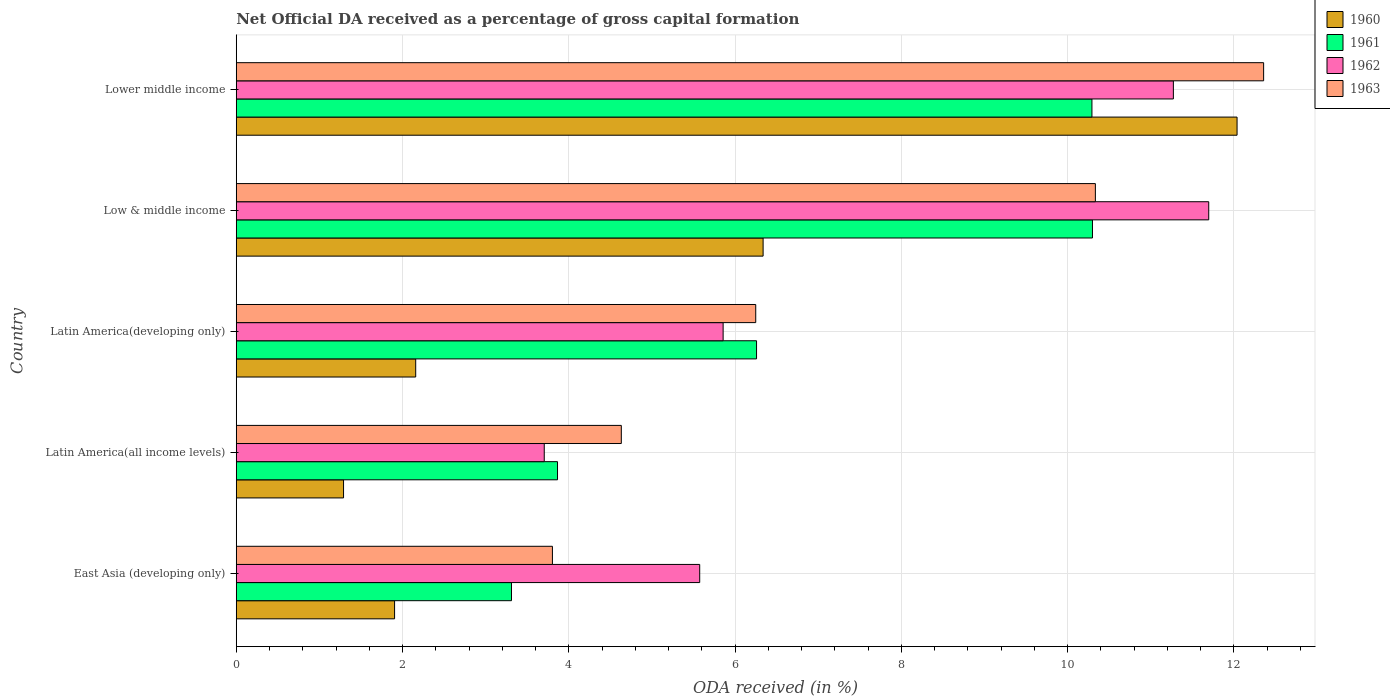How many different coloured bars are there?
Your response must be concise. 4. Are the number of bars per tick equal to the number of legend labels?
Your answer should be very brief. Yes. Are the number of bars on each tick of the Y-axis equal?
Keep it short and to the point. Yes. How many bars are there on the 1st tick from the top?
Offer a terse response. 4. What is the label of the 5th group of bars from the top?
Keep it short and to the point. East Asia (developing only). What is the net ODA received in 1960 in East Asia (developing only)?
Your answer should be very brief. 1.9. Across all countries, what is the maximum net ODA received in 1962?
Your response must be concise. 11.7. Across all countries, what is the minimum net ODA received in 1963?
Keep it short and to the point. 3.8. In which country was the net ODA received in 1960 maximum?
Offer a very short reply. Lower middle income. In which country was the net ODA received in 1962 minimum?
Give a very brief answer. Latin America(all income levels). What is the total net ODA received in 1963 in the graph?
Provide a short and direct response. 37.37. What is the difference between the net ODA received in 1962 in Latin America(all income levels) and that in Latin America(developing only)?
Offer a terse response. -2.15. What is the difference between the net ODA received in 1963 in Latin America(developing only) and the net ODA received in 1961 in Low & middle income?
Keep it short and to the point. -4.05. What is the average net ODA received in 1961 per country?
Offer a terse response. 6.8. What is the difference between the net ODA received in 1963 and net ODA received in 1962 in Lower middle income?
Your answer should be very brief. 1.09. What is the ratio of the net ODA received in 1962 in Low & middle income to that in Lower middle income?
Keep it short and to the point. 1.04. What is the difference between the highest and the second highest net ODA received in 1963?
Ensure brevity in your answer.  2.02. What is the difference between the highest and the lowest net ODA received in 1962?
Ensure brevity in your answer.  7.99. In how many countries, is the net ODA received in 1960 greater than the average net ODA received in 1960 taken over all countries?
Provide a short and direct response. 2. What does the 4th bar from the bottom in Latin America(developing only) represents?
Your response must be concise. 1963. How many bars are there?
Keep it short and to the point. 20. How many countries are there in the graph?
Provide a succinct answer. 5. Are the values on the major ticks of X-axis written in scientific E-notation?
Provide a short and direct response. No. Does the graph contain any zero values?
Make the answer very short. No. Does the graph contain grids?
Provide a short and direct response. Yes. Where does the legend appear in the graph?
Give a very brief answer. Top right. How many legend labels are there?
Provide a short and direct response. 4. What is the title of the graph?
Provide a short and direct response. Net Official DA received as a percentage of gross capital formation. Does "1999" appear as one of the legend labels in the graph?
Offer a terse response. No. What is the label or title of the X-axis?
Your response must be concise. ODA received (in %). What is the ODA received (in %) of 1960 in East Asia (developing only)?
Offer a very short reply. 1.9. What is the ODA received (in %) in 1961 in East Asia (developing only)?
Offer a terse response. 3.31. What is the ODA received (in %) in 1962 in East Asia (developing only)?
Your answer should be compact. 5.57. What is the ODA received (in %) in 1963 in East Asia (developing only)?
Ensure brevity in your answer.  3.8. What is the ODA received (in %) of 1960 in Latin America(all income levels)?
Provide a succinct answer. 1.29. What is the ODA received (in %) in 1961 in Latin America(all income levels)?
Your answer should be compact. 3.86. What is the ODA received (in %) in 1962 in Latin America(all income levels)?
Make the answer very short. 3.7. What is the ODA received (in %) of 1963 in Latin America(all income levels)?
Make the answer very short. 4.63. What is the ODA received (in %) of 1960 in Latin America(developing only)?
Your answer should be very brief. 2.16. What is the ODA received (in %) of 1961 in Latin America(developing only)?
Provide a succinct answer. 6.26. What is the ODA received (in %) in 1962 in Latin America(developing only)?
Your answer should be compact. 5.86. What is the ODA received (in %) in 1963 in Latin America(developing only)?
Your answer should be very brief. 6.25. What is the ODA received (in %) in 1960 in Low & middle income?
Provide a succinct answer. 6.34. What is the ODA received (in %) in 1961 in Low & middle income?
Offer a very short reply. 10.3. What is the ODA received (in %) of 1962 in Low & middle income?
Offer a terse response. 11.7. What is the ODA received (in %) in 1963 in Low & middle income?
Give a very brief answer. 10.33. What is the ODA received (in %) in 1960 in Lower middle income?
Give a very brief answer. 12.04. What is the ODA received (in %) of 1961 in Lower middle income?
Provide a succinct answer. 10.29. What is the ODA received (in %) of 1962 in Lower middle income?
Give a very brief answer. 11.27. What is the ODA received (in %) of 1963 in Lower middle income?
Make the answer very short. 12.36. Across all countries, what is the maximum ODA received (in %) in 1960?
Keep it short and to the point. 12.04. Across all countries, what is the maximum ODA received (in %) in 1961?
Provide a succinct answer. 10.3. Across all countries, what is the maximum ODA received (in %) of 1962?
Offer a very short reply. 11.7. Across all countries, what is the maximum ODA received (in %) of 1963?
Your answer should be compact. 12.36. Across all countries, what is the minimum ODA received (in %) in 1960?
Provide a short and direct response. 1.29. Across all countries, what is the minimum ODA received (in %) of 1961?
Offer a terse response. 3.31. Across all countries, what is the minimum ODA received (in %) of 1962?
Offer a very short reply. 3.7. Across all countries, what is the minimum ODA received (in %) of 1963?
Your answer should be very brief. 3.8. What is the total ODA received (in %) in 1960 in the graph?
Provide a succinct answer. 23.73. What is the total ODA received (in %) in 1961 in the graph?
Make the answer very short. 34.02. What is the total ODA received (in %) in 1962 in the graph?
Offer a very short reply. 38.11. What is the total ODA received (in %) in 1963 in the graph?
Provide a short and direct response. 37.37. What is the difference between the ODA received (in %) in 1960 in East Asia (developing only) and that in Latin America(all income levels)?
Your response must be concise. 0.61. What is the difference between the ODA received (in %) of 1961 in East Asia (developing only) and that in Latin America(all income levels)?
Your answer should be compact. -0.55. What is the difference between the ODA received (in %) of 1962 in East Asia (developing only) and that in Latin America(all income levels)?
Your answer should be very brief. 1.87. What is the difference between the ODA received (in %) in 1963 in East Asia (developing only) and that in Latin America(all income levels)?
Your response must be concise. -0.83. What is the difference between the ODA received (in %) of 1960 in East Asia (developing only) and that in Latin America(developing only)?
Provide a short and direct response. -0.25. What is the difference between the ODA received (in %) in 1961 in East Asia (developing only) and that in Latin America(developing only)?
Make the answer very short. -2.95. What is the difference between the ODA received (in %) in 1962 in East Asia (developing only) and that in Latin America(developing only)?
Your answer should be very brief. -0.28. What is the difference between the ODA received (in %) in 1963 in East Asia (developing only) and that in Latin America(developing only)?
Keep it short and to the point. -2.45. What is the difference between the ODA received (in %) in 1960 in East Asia (developing only) and that in Low & middle income?
Provide a succinct answer. -4.43. What is the difference between the ODA received (in %) of 1961 in East Asia (developing only) and that in Low & middle income?
Keep it short and to the point. -6.99. What is the difference between the ODA received (in %) of 1962 in East Asia (developing only) and that in Low & middle income?
Your answer should be very brief. -6.12. What is the difference between the ODA received (in %) of 1963 in East Asia (developing only) and that in Low & middle income?
Offer a terse response. -6.53. What is the difference between the ODA received (in %) of 1960 in East Asia (developing only) and that in Lower middle income?
Offer a very short reply. -10.13. What is the difference between the ODA received (in %) of 1961 in East Asia (developing only) and that in Lower middle income?
Offer a terse response. -6.98. What is the difference between the ODA received (in %) in 1962 in East Asia (developing only) and that in Lower middle income?
Your answer should be very brief. -5.7. What is the difference between the ODA received (in %) of 1963 in East Asia (developing only) and that in Lower middle income?
Offer a terse response. -8.55. What is the difference between the ODA received (in %) in 1960 in Latin America(all income levels) and that in Latin America(developing only)?
Ensure brevity in your answer.  -0.87. What is the difference between the ODA received (in %) of 1961 in Latin America(all income levels) and that in Latin America(developing only)?
Keep it short and to the point. -2.39. What is the difference between the ODA received (in %) of 1962 in Latin America(all income levels) and that in Latin America(developing only)?
Make the answer very short. -2.15. What is the difference between the ODA received (in %) in 1963 in Latin America(all income levels) and that in Latin America(developing only)?
Provide a short and direct response. -1.62. What is the difference between the ODA received (in %) of 1960 in Latin America(all income levels) and that in Low & middle income?
Your response must be concise. -5.05. What is the difference between the ODA received (in %) of 1961 in Latin America(all income levels) and that in Low & middle income?
Your answer should be very brief. -6.43. What is the difference between the ODA received (in %) of 1962 in Latin America(all income levels) and that in Low & middle income?
Offer a terse response. -7.99. What is the difference between the ODA received (in %) in 1963 in Latin America(all income levels) and that in Low & middle income?
Offer a very short reply. -5.7. What is the difference between the ODA received (in %) in 1960 in Latin America(all income levels) and that in Lower middle income?
Ensure brevity in your answer.  -10.75. What is the difference between the ODA received (in %) in 1961 in Latin America(all income levels) and that in Lower middle income?
Offer a very short reply. -6.43. What is the difference between the ODA received (in %) in 1962 in Latin America(all income levels) and that in Lower middle income?
Your answer should be very brief. -7.57. What is the difference between the ODA received (in %) of 1963 in Latin America(all income levels) and that in Lower middle income?
Give a very brief answer. -7.73. What is the difference between the ODA received (in %) of 1960 in Latin America(developing only) and that in Low & middle income?
Your answer should be compact. -4.18. What is the difference between the ODA received (in %) in 1961 in Latin America(developing only) and that in Low & middle income?
Keep it short and to the point. -4.04. What is the difference between the ODA received (in %) of 1962 in Latin America(developing only) and that in Low & middle income?
Offer a very short reply. -5.84. What is the difference between the ODA received (in %) in 1963 in Latin America(developing only) and that in Low & middle income?
Provide a succinct answer. -4.09. What is the difference between the ODA received (in %) in 1960 in Latin America(developing only) and that in Lower middle income?
Ensure brevity in your answer.  -9.88. What is the difference between the ODA received (in %) of 1961 in Latin America(developing only) and that in Lower middle income?
Your answer should be very brief. -4.03. What is the difference between the ODA received (in %) in 1962 in Latin America(developing only) and that in Lower middle income?
Provide a succinct answer. -5.42. What is the difference between the ODA received (in %) in 1963 in Latin America(developing only) and that in Lower middle income?
Your response must be concise. -6.11. What is the difference between the ODA received (in %) in 1960 in Low & middle income and that in Lower middle income?
Provide a succinct answer. -5.7. What is the difference between the ODA received (in %) in 1961 in Low & middle income and that in Lower middle income?
Ensure brevity in your answer.  0.01. What is the difference between the ODA received (in %) of 1962 in Low & middle income and that in Lower middle income?
Provide a succinct answer. 0.43. What is the difference between the ODA received (in %) in 1963 in Low & middle income and that in Lower middle income?
Offer a terse response. -2.02. What is the difference between the ODA received (in %) of 1960 in East Asia (developing only) and the ODA received (in %) of 1961 in Latin America(all income levels)?
Offer a terse response. -1.96. What is the difference between the ODA received (in %) in 1960 in East Asia (developing only) and the ODA received (in %) in 1962 in Latin America(all income levels)?
Your response must be concise. -1.8. What is the difference between the ODA received (in %) of 1960 in East Asia (developing only) and the ODA received (in %) of 1963 in Latin America(all income levels)?
Provide a succinct answer. -2.73. What is the difference between the ODA received (in %) in 1961 in East Asia (developing only) and the ODA received (in %) in 1962 in Latin America(all income levels)?
Offer a terse response. -0.39. What is the difference between the ODA received (in %) in 1961 in East Asia (developing only) and the ODA received (in %) in 1963 in Latin America(all income levels)?
Give a very brief answer. -1.32. What is the difference between the ODA received (in %) of 1962 in East Asia (developing only) and the ODA received (in %) of 1963 in Latin America(all income levels)?
Keep it short and to the point. 0.94. What is the difference between the ODA received (in %) in 1960 in East Asia (developing only) and the ODA received (in %) in 1961 in Latin America(developing only)?
Ensure brevity in your answer.  -4.35. What is the difference between the ODA received (in %) of 1960 in East Asia (developing only) and the ODA received (in %) of 1962 in Latin America(developing only)?
Your response must be concise. -3.95. What is the difference between the ODA received (in %) in 1960 in East Asia (developing only) and the ODA received (in %) in 1963 in Latin America(developing only)?
Your answer should be very brief. -4.34. What is the difference between the ODA received (in %) of 1961 in East Asia (developing only) and the ODA received (in %) of 1962 in Latin America(developing only)?
Your response must be concise. -2.55. What is the difference between the ODA received (in %) of 1961 in East Asia (developing only) and the ODA received (in %) of 1963 in Latin America(developing only)?
Give a very brief answer. -2.94. What is the difference between the ODA received (in %) in 1962 in East Asia (developing only) and the ODA received (in %) in 1963 in Latin America(developing only)?
Provide a succinct answer. -0.67. What is the difference between the ODA received (in %) in 1960 in East Asia (developing only) and the ODA received (in %) in 1961 in Low & middle income?
Give a very brief answer. -8.39. What is the difference between the ODA received (in %) in 1960 in East Asia (developing only) and the ODA received (in %) in 1962 in Low & middle income?
Your answer should be compact. -9.79. What is the difference between the ODA received (in %) in 1960 in East Asia (developing only) and the ODA received (in %) in 1963 in Low & middle income?
Your response must be concise. -8.43. What is the difference between the ODA received (in %) of 1961 in East Asia (developing only) and the ODA received (in %) of 1962 in Low & middle income?
Offer a terse response. -8.39. What is the difference between the ODA received (in %) of 1961 in East Asia (developing only) and the ODA received (in %) of 1963 in Low & middle income?
Your response must be concise. -7.02. What is the difference between the ODA received (in %) in 1962 in East Asia (developing only) and the ODA received (in %) in 1963 in Low & middle income?
Your response must be concise. -4.76. What is the difference between the ODA received (in %) in 1960 in East Asia (developing only) and the ODA received (in %) in 1961 in Lower middle income?
Provide a short and direct response. -8.39. What is the difference between the ODA received (in %) of 1960 in East Asia (developing only) and the ODA received (in %) of 1962 in Lower middle income?
Give a very brief answer. -9.37. What is the difference between the ODA received (in %) in 1960 in East Asia (developing only) and the ODA received (in %) in 1963 in Lower middle income?
Offer a terse response. -10.45. What is the difference between the ODA received (in %) of 1961 in East Asia (developing only) and the ODA received (in %) of 1962 in Lower middle income?
Offer a terse response. -7.96. What is the difference between the ODA received (in %) in 1961 in East Asia (developing only) and the ODA received (in %) in 1963 in Lower middle income?
Give a very brief answer. -9.05. What is the difference between the ODA received (in %) in 1962 in East Asia (developing only) and the ODA received (in %) in 1963 in Lower middle income?
Your response must be concise. -6.78. What is the difference between the ODA received (in %) of 1960 in Latin America(all income levels) and the ODA received (in %) of 1961 in Latin America(developing only)?
Keep it short and to the point. -4.97. What is the difference between the ODA received (in %) in 1960 in Latin America(all income levels) and the ODA received (in %) in 1962 in Latin America(developing only)?
Provide a short and direct response. -4.57. What is the difference between the ODA received (in %) in 1960 in Latin America(all income levels) and the ODA received (in %) in 1963 in Latin America(developing only)?
Your answer should be compact. -4.96. What is the difference between the ODA received (in %) of 1961 in Latin America(all income levels) and the ODA received (in %) of 1962 in Latin America(developing only)?
Give a very brief answer. -1.99. What is the difference between the ODA received (in %) in 1961 in Latin America(all income levels) and the ODA received (in %) in 1963 in Latin America(developing only)?
Your response must be concise. -2.38. What is the difference between the ODA received (in %) in 1962 in Latin America(all income levels) and the ODA received (in %) in 1963 in Latin America(developing only)?
Keep it short and to the point. -2.54. What is the difference between the ODA received (in %) of 1960 in Latin America(all income levels) and the ODA received (in %) of 1961 in Low & middle income?
Your answer should be very brief. -9.01. What is the difference between the ODA received (in %) of 1960 in Latin America(all income levels) and the ODA received (in %) of 1962 in Low & middle income?
Provide a succinct answer. -10.41. What is the difference between the ODA received (in %) of 1960 in Latin America(all income levels) and the ODA received (in %) of 1963 in Low & middle income?
Give a very brief answer. -9.04. What is the difference between the ODA received (in %) in 1961 in Latin America(all income levels) and the ODA received (in %) in 1962 in Low & middle income?
Provide a succinct answer. -7.83. What is the difference between the ODA received (in %) of 1961 in Latin America(all income levels) and the ODA received (in %) of 1963 in Low & middle income?
Give a very brief answer. -6.47. What is the difference between the ODA received (in %) of 1962 in Latin America(all income levels) and the ODA received (in %) of 1963 in Low & middle income?
Give a very brief answer. -6.63. What is the difference between the ODA received (in %) of 1960 in Latin America(all income levels) and the ODA received (in %) of 1961 in Lower middle income?
Make the answer very short. -9. What is the difference between the ODA received (in %) in 1960 in Latin America(all income levels) and the ODA received (in %) in 1962 in Lower middle income?
Your answer should be compact. -9.98. What is the difference between the ODA received (in %) in 1960 in Latin America(all income levels) and the ODA received (in %) in 1963 in Lower middle income?
Keep it short and to the point. -11.07. What is the difference between the ODA received (in %) in 1961 in Latin America(all income levels) and the ODA received (in %) in 1962 in Lower middle income?
Your answer should be compact. -7.41. What is the difference between the ODA received (in %) in 1961 in Latin America(all income levels) and the ODA received (in %) in 1963 in Lower middle income?
Make the answer very short. -8.49. What is the difference between the ODA received (in %) in 1962 in Latin America(all income levels) and the ODA received (in %) in 1963 in Lower middle income?
Your answer should be compact. -8.65. What is the difference between the ODA received (in %) of 1960 in Latin America(developing only) and the ODA received (in %) of 1961 in Low & middle income?
Ensure brevity in your answer.  -8.14. What is the difference between the ODA received (in %) in 1960 in Latin America(developing only) and the ODA received (in %) in 1962 in Low & middle income?
Give a very brief answer. -9.54. What is the difference between the ODA received (in %) of 1960 in Latin America(developing only) and the ODA received (in %) of 1963 in Low & middle income?
Give a very brief answer. -8.18. What is the difference between the ODA received (in %) in 1961 in Latin America(developing only) and the ODA received (in %) in 1962 in Low & middle income?
Offer a terse response. -5.44. What is the difference between the ODA received (in %) in 1961 in Latin America(developing only) and the ODA received (in %) in 1963 in Low & middle income?
Your answer should be very brief. -4.08. What is the difference between the ODA received (in %) of 1962 in Latin America(developing only) and the ODA received (in %) of 1963 in Low & middle income?
Ensure brevity in your answer.  -4.48. What is the difference between the ODA received (in %) in 1960 in Latin America(developing only) and the ODA received (in %) in 1961 in Lower middle income?
Your response must be concise. -8.13. What is the difference between the ODA received (in %) of 1960 in Latin America(developing only) and the ODA received (in %) of 1962 in Lower middle income?
Keep it short and to the point. -9.11. What is the difference between the ODA received (in %) of 1960 in Latin America(developing only) and the ODA received (in %) of 1963 in Lower middle income?
Give a very brief answer. -10.2. What is the difference between the ODA received (in %) in 1961 in Latin America(developing only) and the ODA received (in %) in 1962 in Lower middle income?
Your answer should be very brief. -5.01. What is the difference between the ODA received (in %) of 1961 in Latin America(developing only) and the ODA received (in %) of 1963 in Lower middle income?
Provide a short and direct response. -6.1. What is the difference between the ODA received (in %) in 1962 in Latin America(developing only) and the ODA received (in %) in 1963 in Lower middle income?
Ensure brevity in your answer.  -6.5. What is the difference between the ODA received (in %) in 1960 in Low & middle income and the ODA received (in %) in 1961 in Lower middle income?
Provide a succinct answer. -3.96. What is the difference between the ODA received (in %) of 1960 in Low & middle income and the ODA received (in %) of 1962 in Lower middle income?
Ensure brevity in your answer.  -4.93. What is the difference between the ODA received (in %) in 1960 in Low & middle income and the ODA received (in %) in 1963 in Lower middle income?
Provide a short and direct response. -6.02. What is the difference between the ODA received (in %) in 1961 in Low & middle income and the ODA received (in %) in 1962 in Lower middle income?
Provide a succinct answer. -0.97. What is the difference between the ODA received (in %) of 1961 in Low & middle income and the ODA received (in %) of 1963 in Lower middle income?
Your response must be concise. -2.06. What is the difference between the ODA received (in %) in 1962 in Low & middle income and the ODA received (in %) in 1963 in Lower middle income?
Provide a succinct answer. -0.66. What is the average ODA received (in %) in 1960 per country?
Your answer should be compact. 4.75. What is the average ODA received (in %) of 1961 per country?
Your answer should be very brief. 6.8. What is the average ODA received (in %) of 1962 per country?
Make the answer very short. 7.62. What is the average ODA received (in %) of 1963 per country?
Make the answer very short. 7.47. What is the difference between the ODA received (in %) in 1960 and ODA received (in %) in 1961 in East Asia (developing only)?
Your answer should be compact. -1.41. What is the difference between the ODA received (in %) of 1960 and ODA received (in %) of 1962 in East Asia (developing only)?
Make the answer very short. -3.67. What is the difference between the ODA received (in %) of 1960 and ODA received (in %) of 1963 in East Asia (developing only)?
Offer a terse response. -1.9. What is the difference between the ODA received (in %) of 1961 and ODA received (in %) of 1962 in East Asia (developing only)?
Keep it short and to the point. -2.26. What is the difference between the ODA received (in %) of 1961 and ODA received (in %) of 1963 in East Asia (developing only)?
Keep it short and to the point. -0.49. What is the difference between the ODA received (in %) of 1962 and ODA received (in %) of 1963 in East Asia (developing only)?
Your response must be concise. 1.77. What is the difference between the ODA received (in %) of 1960 and ODA received (in %) of 1961 in Latin America(all income levels)?
Keep it short and to the point. -2.57. What is the difference between the ODA received (in %) in 1960 and ODA received (in %) in 1962 in Latin America(all income levels)?
Ensure brevity in your answer.  -2.41. What is the difference between the ODA received (in %) of 1960 and ODA received (in %) of 1963 in Latin America(all income levels)?
Your answer should be compact. -3.34. What is the difference between the ODA received (in %) in 1961 and ODA received (in %) in 1962 in Latin America(all income levels)?
Your answer should be very brief. 0.16. What is the difference between the ODA received (in %) of 1961 and ODA received (in %) of 1963 in Latin America(all income levels)?
Ensure brevity in your answer.  -0.77. What is the difference between the ODA received (in %) in 1962 and ODA received (in %) in 1963 in Latin America(all income levels)?
Offer a very short reply. -0.93. What is the difference between the ODA received (in %) in 1960 and ODA received (in %) in 1962 in Latin America(developing only)?
Provide a short and direct response. -3.7. What is the difference between the ODA received (in %) in 1960 and ODA received (in %) in 1963 in Latin America(developing only)?
Your answer should be compact. -4.09. What is the difference between the ODA received (in %) of 1961 and ODA received (in %) of 1962 in Latin America(developing only)?
Keep it short and to the point. 0.4. What is the difference between the ODA received (in %) of 1961 and ODA received (in %) of 1963 in Latin America(developing only)?
Ensure brevity in your answer.  0.01. What is the difference between the ODA received (in %) of 1962 and ODA received (in %) of 1963 in Latin America(developing only)?
Offer a very short reply. -0.39. What is the difference between the ODA received (in %) in 1960 and ODA received (in %) in 1961 in Low & middle income?
Offer a terse response. -3.96. What is the difference between the ODA received (in %) in 1960 and ODA received (in %) in 1962 in Low & middle income?
Provide a succinct answer. -5.36. What is the difference between the ODA received (in %) in 1960 and ODA received (in %) in 1963 in Low & middle income?
Your answer should be very brief. -4. What is the difference between the ODA received (in %) in 1961 and ODA received (in %) in 1962 in Low & middle income?
Make the answer very short. -1.4. What is the difference between the ODA received (in %) in 1961 and ODA received (in %) in 1963 in Low & middle income?
Your response must be concise. -0.03. What is the difference between the ODA received (in %) in 1962 and ODA received (in %) in 1963 in Low & middle income?
Your answer should be compact. 1.36. What is the difference between the ODA received (in %) of 1960 and ODA received (in %) of 1961 in Lower middle income?
Offer a very short reply. 1.75. What is the difference between the ODA received (in %) in 1960 and ODA received (in %) in 1962 in Lower middle income?
Ensure brevity in your answer.  0.77. What is the difference between the ODA received (in %) in 1960 and ODA received (in %) in 1963 in Lower middle income?
Give a very brief answer. -0.32. What is the difference between the ODA received (in %) in 1961 and ODA received (in %) in 1962 in Lower middle income?
Make the answer very short. -0.98. What is the difference between the ODA received (in %) of 1961 and ODA received (in %) of 1963 in Lower middle income?
Make the answer very short. -2.07. What is the difference between the ODA received (in %) of 1962 and ODA received (in %) of 1963 in Lower middle income?
Make the answer very short. -1.09. What is the ratio of the ODA received (in %) in 1960 in East Asia (developing only) to that in Latin America(all income levels)?
Keep it short and to the point. 1.48. What is the ratio of the ODA received (in %) in 1961 in East Asia (developing only) to that in Latin America(all income levels)?
Ensure brevity in your answer.  0.86. What is the ratio of the ODA received (in %) in 1962 in East Asia (developing only) to that in Latin America(all income levels)?
Ensure brevity in your answer.  1.5. What is the ratio of the ODA received (in %) in 1963 in East Asia (developing only) to that in Latin America(all income levels)?
Ensure brevity in your answer.  0.82. What is the ratio of the ODA received (in %) in 1960 in East Asia (developing only) to that in Latin America(developing only)?
Make the answer very short. 0.88. What is the ratio of the ODA received (in %) of 1961 in East Asia (developing only) to that in Latin America(developing only)?
Offer a very short reply. 0.53. What is the ratio of the ODA received (in %) in 1962 in East Asia (developing only) to that in Latin America(developing only)?
Your answer should be very brief. 0.95. What is the ratio of the ODA received (in %) in 1963 in East Asia (developing only) to that in Latin America(developing only)?
Your answer should be very brief. 0.61. What is the ratio of the ODA received (in %) in 1960 in East Asia (developing only) to that in Low & middle income?
Your response must be concise. 0.3. What is the ratio of the ODA received (in %) of 1961 in East Asia (developing only) to that in Low & middle income?
Offer a terse response. 0.32. What is the ratio of the ODA received (in %) in 1962 in East Asia (developing only) to that in Low & middle income?
Your response must be concise. 0.48. What is the ratio of the ODA received (in %) in 1963 in East Asia (developing only) to that in Low & middle income?
Your answer should be very brief. 0.37. What is the ratio of the ODA received (in %) of 1960 in East Asia (developing only) to that in Lower middle income?
Your answer should be very brief. 0.16. What is the ratio of the ODA received (in %) of 1961 in East Asia (developing only) to that in Lower middle income?
Your response must be concise. 0.32. What is the ratio of the ODA received (in %) of 1962 in East Asia (developing only) to that in Lower middle income?
Give a very brief answer. 0.49. What is the ratio of the ODA received (in %) of 1963 in East Asia (developing only) to that in Lower middle income?
Keep it short and to the point. 0.31. What is the ratio of the ODA received (in %) in 1960 in Latin America(all income levels) to that in Latin America(developing only)?
Your answer should be very brief. 0.6. What is the ratio of the ODA received (in %) of 1961 in Latin America(all income levels) to that in Latin America(developing only)?
Make the answer very short. 0.62. What is the ratio of the ODA received (in %) of 1962 in Latin America(all income levels) to that in Latin America(developing only)?
Keep it short and to the point. 0.63. What is the ratio of the ODA received (in %) of 1963 in Latin America(all income levels) to that in Latin America(developing only)?
Provide a succinct answer. 0.74. What is the ratio of the ODA received (in %) of 1960 in Latin America(all income levels) to that in Low & middle income?
Provide a short and direct response. 0.2. What is the ratio of the ODA received (in %) of 1961 in Latin America(all income levels) to that in Low & middle income?
Ensure brevity in your answer.  0.38. What is the ratio of the ODA received (in %) of 1962 in Latin America(all income levels) to that in Low & middle income?
Make the answer very short. 0.32. What is the ratio of the ODA received (in %) of 1963 in Latin America(all income levels) to that in Low & middle income?
Your answer should be very brief. 0.45. What is the ratio of the ODA received (in %) of 1960 in Latin America(all income levels) to that in Lower middle income?
Make the answer very short. 0.11. What is the ratio of the ODA received (in %) in 1961 in Latin America(all income levels) to that in Lower middle income?
Provide a short and direct response. 0.38. What is the ratio of the ODA received (in %) of 1962 in Latin America(all income levels) to that in Lower middle income?
Keep it short and to the point. 0.33. What is the ratio of the ODA received (in %) in 1963 in Latin America(all income levels) to that in Lower middle income?
Your answer should be very brief. 0.37. What is the ratio of the ODA received (in %) in 1960 in Latin America(developing only) to that in Low & middle income?
Offer a terse response. 0.34. What is the ratio of the ODA received (in %) in 1961 in Latin America(developing only) to that in Low & middle income?
Offer a terse response. 0.61. What is the ratio of the ODA received (in %) in 1962 in Latin America(developing only) to that in Low & middle income?
Give a very brief answer. 0.5. What is the ratio of the ODA received (in %) of 1963 in Latin America(developing only) to that in Low & middle income?
Your answer should be compact. 0.6. What is the ratio of the ODA received (in %) in 1960 in Latin America(developing only) to that in Lower middle income?
Your response must be concise. 0.18. What is the ratio of the ODA received (in %) of 1961 in Latin America(developing only) to that in Lower middle income?
Offer a terse response. 0.61. What is the ratio of the ODA received (in %) in 1962 in Latin America(developing only) to that in Lower middle income?
Your answer should be compact. 0.52. What is the ratio of the ODA received (in %) in 1963 in Latin America(developing only) to that in Lower middle income?
Give a very brief answer. 0.51. What is the ratio of the ODA received (in %) in 1960 in Low & middle income to that in Lower middle income?
Ensure brevity in your answer.  0.53. What is the ratio of the ODA received (in %) of 1962 in Low & middle income to that in Lower middle income?
Offer a terse response. 1.04. What is the ratio of the ODA received (in %) of 1963 in Low & middle income to that in Lower middle income?
Offer a very short reply. 0.84. What is the difference between the highest and the second highest ODA received (in %) of 1960?
Ensure brevity in your answer.  5.7. What is the difference between the highest and the second highest ODA received (in %) in 1961?
Make the answer very short. 0.01. What is the difference between the highest and the second highest ODA received (in %) of 1962?
Your answer should be very brief. 0.43. What is the difference between the highest and the second highest ODA received (in %) in 1963?
Ensure brevity in your answer.  2.02. What is the difference between the highest and the lowest ODA received (in %) of 1960?
Offer a terse response. 10.75. What is the difference between the highest and the lowest ODA received (in %) in 1961?
Your response must be concise. 6.99. What is the difference between the highest and the lowest ODA received (in %) of 1962?
Offer a very short reply. 7.99. What is the difference between the highest and the lowest ODA received (in %) in 1963?
Your answer should be compact. 8.55. 